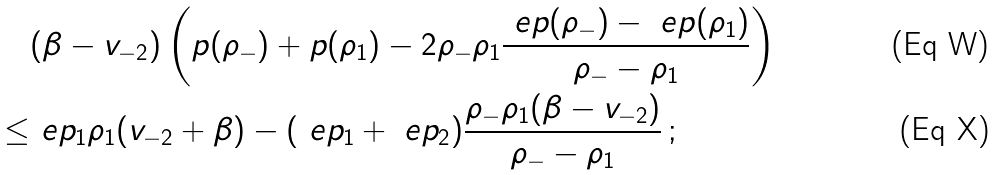Convert formula to latex. <formula><loc_0><loc_0><loc_500><loc_500>& ( \beta - v _ { - 2 } ) \left ( p ( \rho _ { - } ) + p ( \rho _ { 1 } ) - 2 \rho _ { - } \rho _ { 1 } \frac { \ e p ( \rho _ { - } ) - \ e p ( \rho _ { 1 } ) } { \rho _ { - } - \rho _ { 1 } } \right ) \\ \leq & \ e p _ { 1 } \rho _ { 1 } ( v _ { - 2 } + \beta ) - ( \ e p _ { 1 } + \ e p _ { 2 } ) \frac { \rho _ { - } \rho _ { 1 } ( \beta - v _ { - 2 } ) } { \rho _ { - } - \rho _ { 1 } } \, ;</formula> 